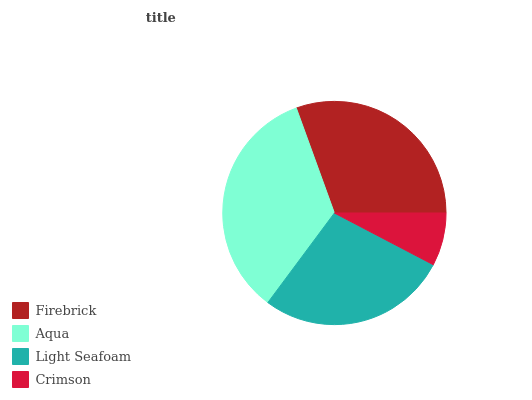Is Crimson the minimum?
Answer yes or no. Yes. Is Aqua the maximum?
Answer yes or no. Yes. Is Light Seafoam the minimum?
Answer yes or no. No. Is Light Seafoam the maximum?
Answer yes or no. No. Is Aqua greater than Light Seafoam?
Answer yes or no. Yes. Is Light Seafoam less than Aqua?
Answer yes or no. Yes. Is Light Seafoam greater than Aqua?
Answer yes or no. No. Is Aqua less than Light Seafoam?
Answer yes or no. No. Is Firebrick the high median?
Answer yes or no. Yes. Is Light Seafoam the low median?
Answer yes or no. Yes. Is Light Seafoam the high median?
Answer yes or no. No. Is Crimson the low median?
Answer yes or no. No. 